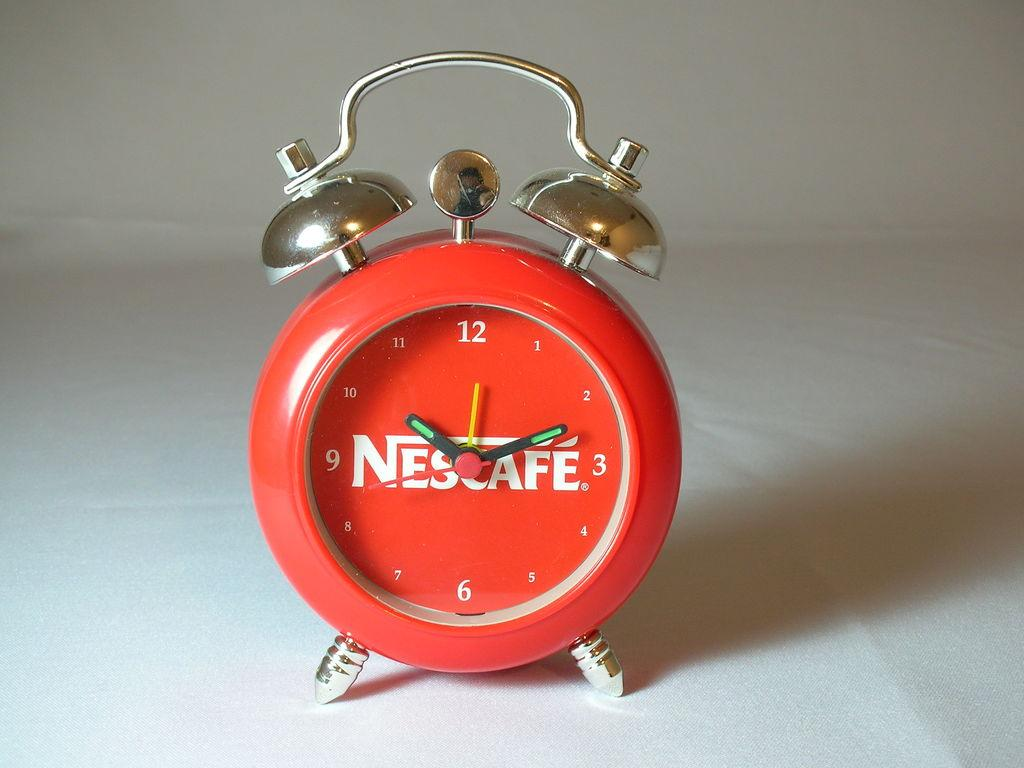<image>
Share a concise interpretation of the image provided. The alarm clock here is from the company NesCafe 